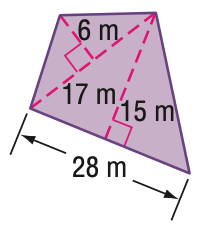Answer the mathemtical geometry problem and directly provide the correct option letter.
Question: Find the area of the figure. Round to the nearest tenth if necessary.
Choices: A: 261 B: 312 C: 471 D: 522 A 